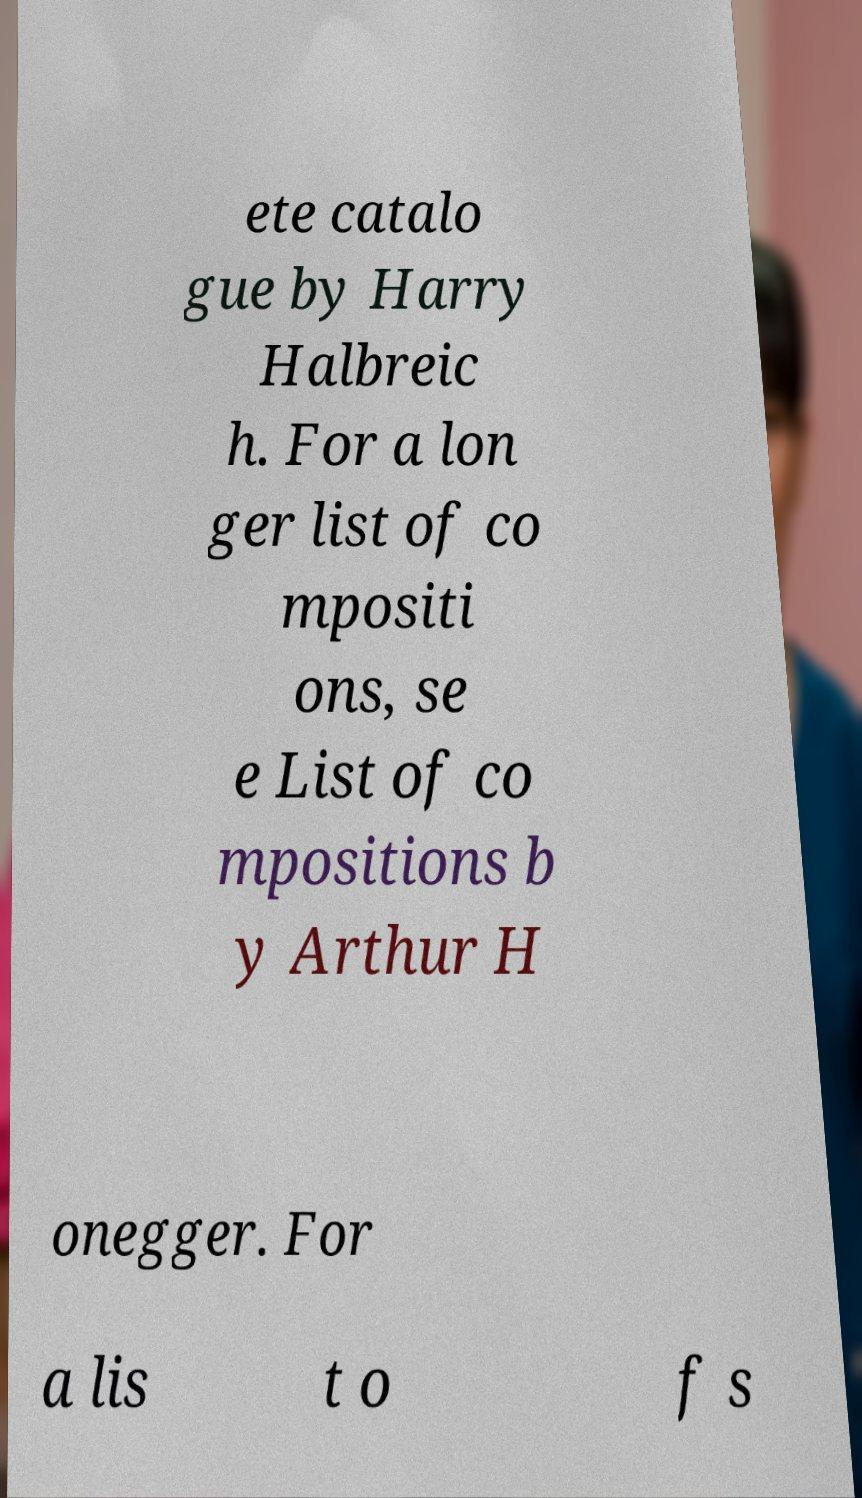Can you accurately transcribe the text from the provided image for me? ete catalo gue by Harry Halbreic h. For a lon ger list of co mpositi ons, se e List of co mpositions b y Arthur H onegger. For a lis t o f s 